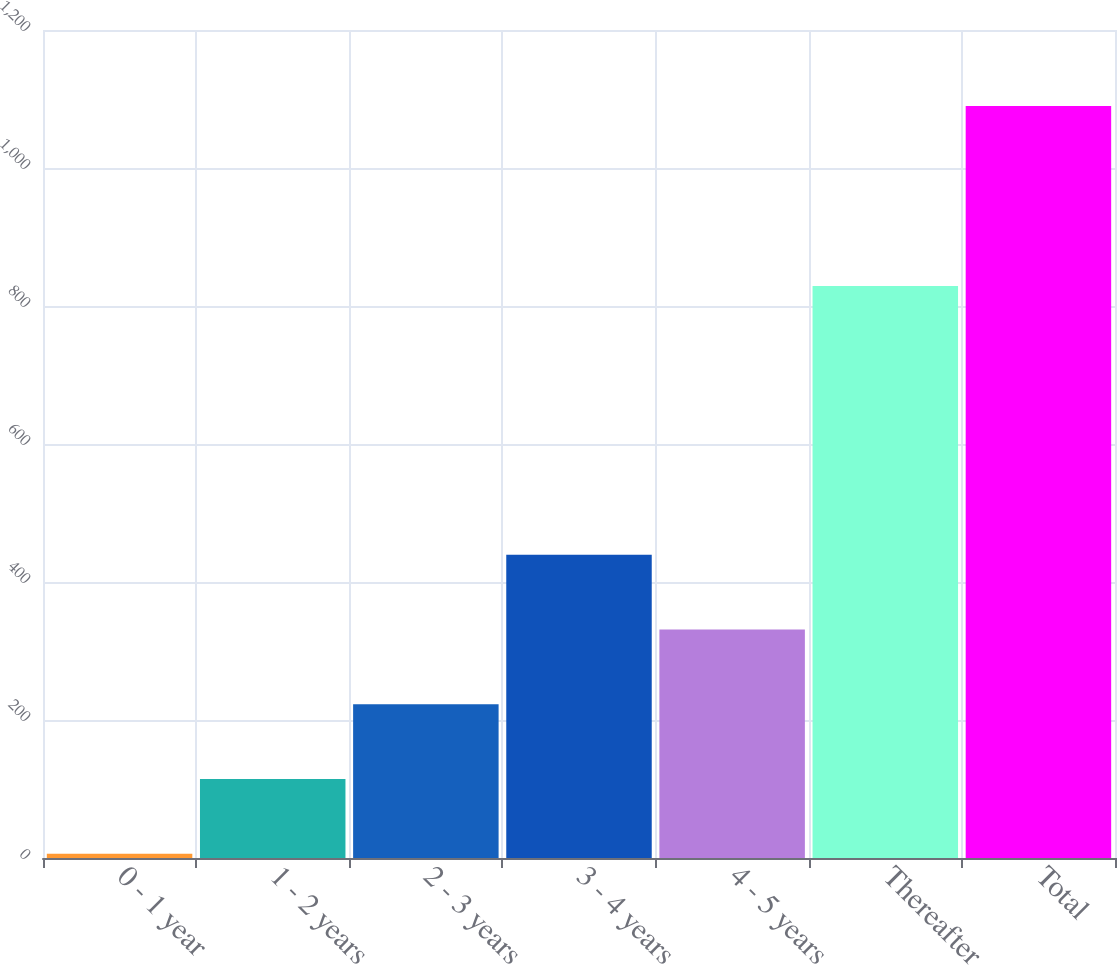Convert chart to OTSL. <chart><loc_0><loc_0><loc_500><loc_500><bar_chart><fcel>0 - 1 year<fcel>1 - 2 years<fcel>2 - 3 years<fcel>3 - 4 years<fcel>4 - 5 years<fcel>Thereafter<fcel>Total<nl><fcel>6<fcel>114.4<fcel>222.8<fcel>439.6<fcel>331.2<fcel>829<fcel>1090<nl></chart> 